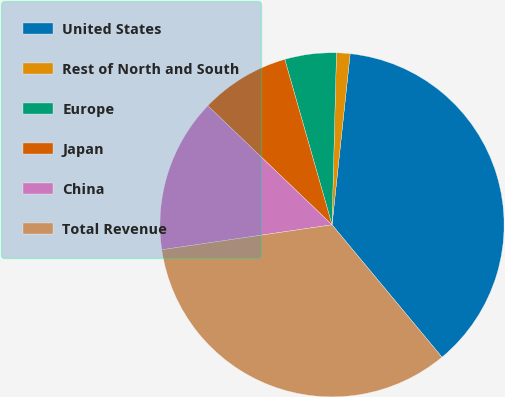<chart> <loc_0><loc_0><loc_500><loc_500><pie_chart><fcel>United States<fcel>Rest of North and South<fcel>Europe<fcel>Japan<fcel>China<fcel>Total Revenue<nl><fcel>37.29%<fcel>1.27%<fcel>4.84%<fcel>8.41%<fcel>14.48%<fcel>33.72%<nl></chart> 